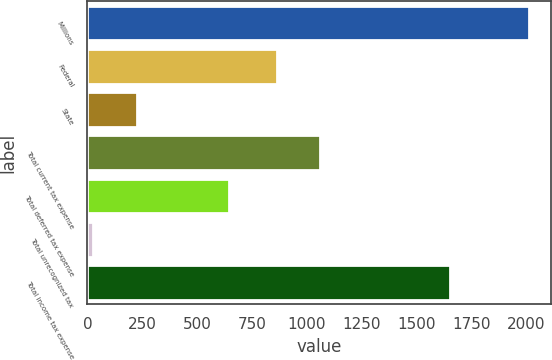Convert chart. <chart><loc_0><loc_0><loc_500><loc_500><bar_chart><fcel>Millions<fcel>Federal<fcel>State<fcel>Total current tax expense<fcel>Total deferred tax expense<fcel>Total unrecognized tax<fcel>Total income tax expense<nl><fcel>2010<fcel>862<fcel>223.5<fcel>1060.5<fcel>647<fcel>25<fcel>1653<nl></chart> 